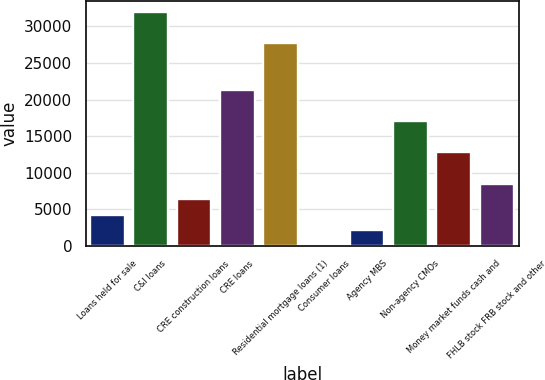Convert chart to OTSL. <chart><loc_0><loc_0><loc_500><loc_500><bar_chart><fcel>Loans held for sale<fcel>C&I loans<fcel>CRE construction loans<fcel>CRE loans<fcel>Residential mortgage loans (1)<fcel>Consumer loans<fcel>Agency MBS<fcel>Non-agency CMOs<fcel>Money market funds cash and<fcel>FHLB stock FRB stock and other<nl><fcel>4266.6<fcel>31928<fcel>6394.4<fcel>21289<fcel>27672.4<fcel>11<fcel>2138.8<fcel>17033.4<fcel>12777.8<fcel>8522.2<nl></chart> 